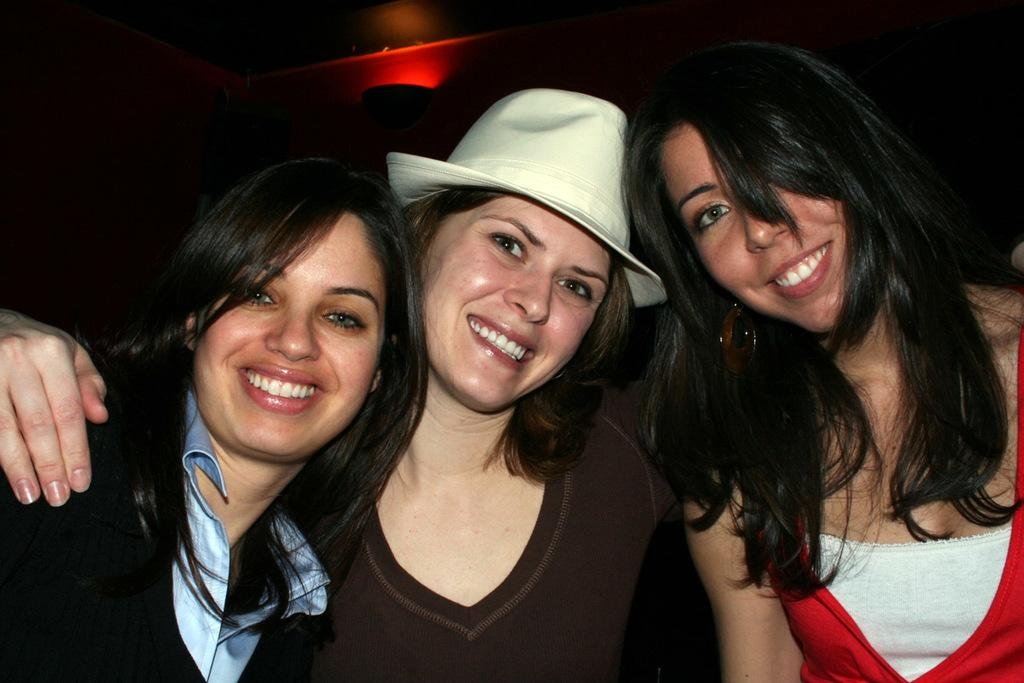How many people are present in the image? There are three people in the image. What expressions do the people have on their faces? The people are wearing smiles on their faces. What can be seen in the background of the image? There is light visible in the background of the image. What type of metal is used to make the square frame in the image? There is no square frame present in the image, so it is not possible to determine what type of metal might be used. 